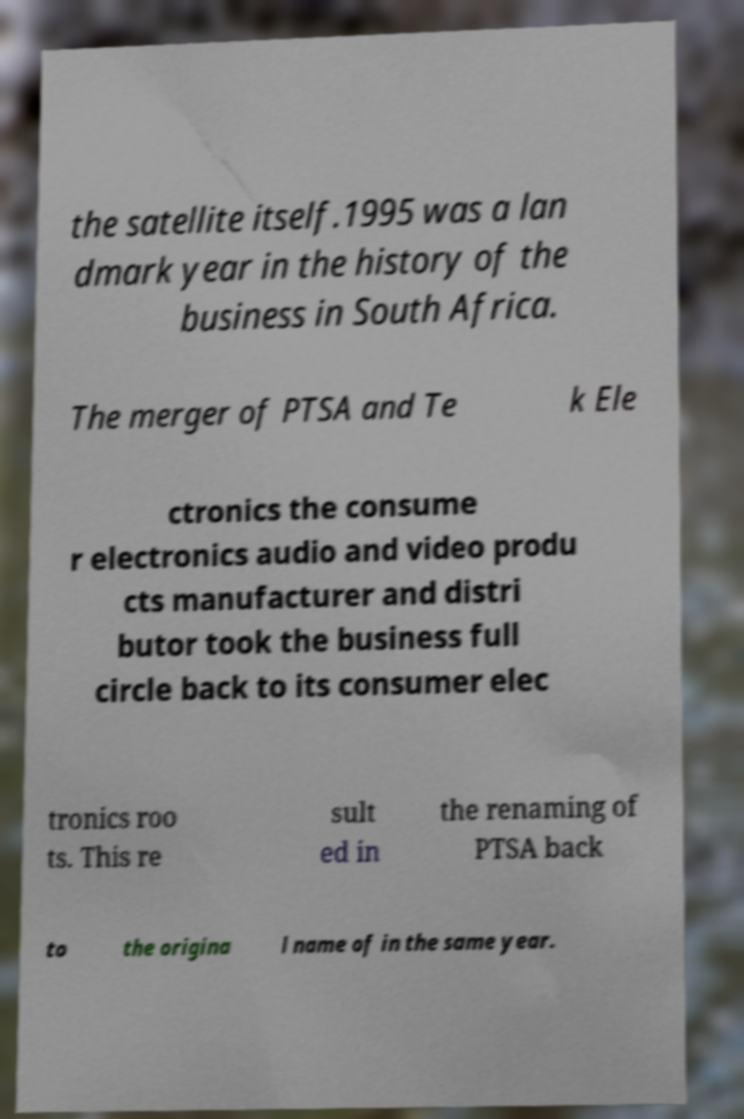There's text embedded in this image that I need extracted. Can you transcribe it verbatim? the satellite itself.1995 was a lan dmark year in the history of the business in South Africa. The merger of PTSA and Te k Ele ctronics the consume r electronics audio and video produ cts manufacturer and distri butor took the business full circle back to its consumer elec tronics roo ts. This re sult ed in the renaming of PTSA back to the origina l name of in the same year. 